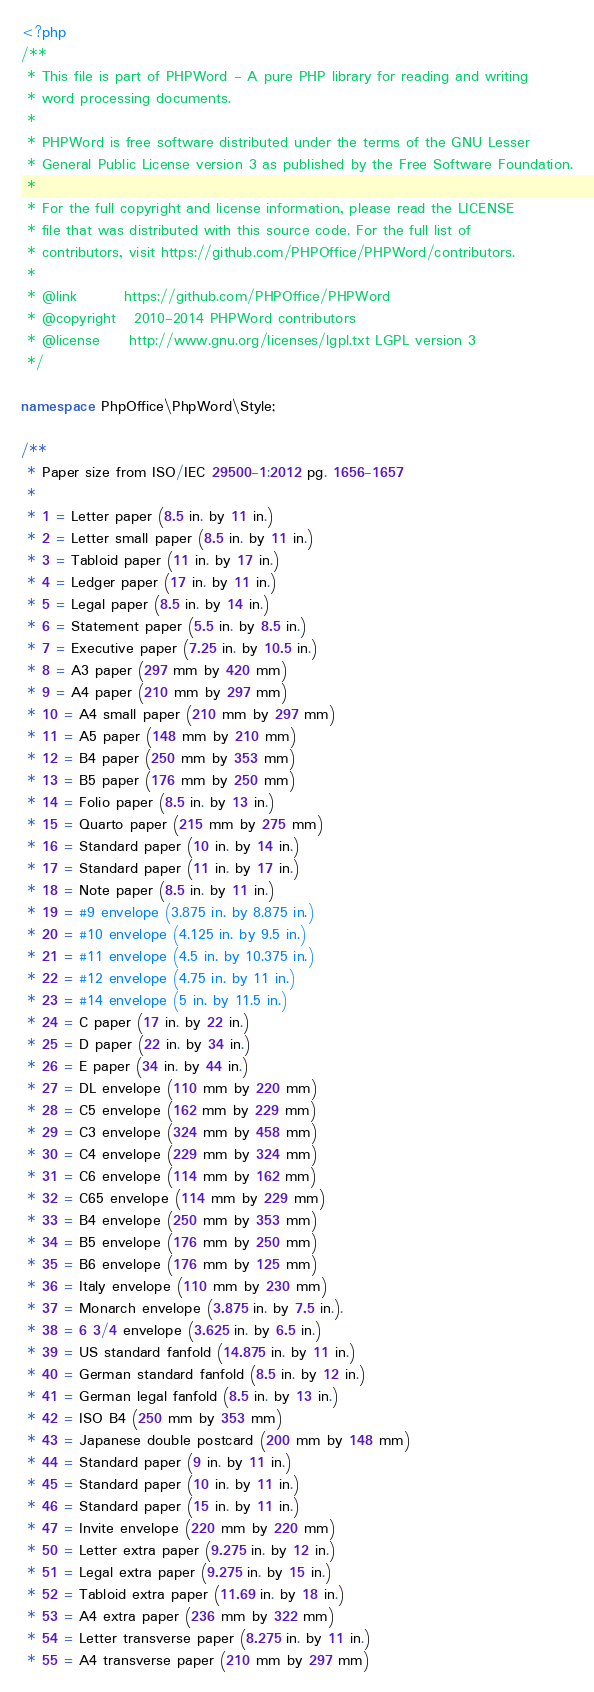<code> <loc_0><loc_0><loc_500><loc_500><_PHP_><?php
/**
 * This file is part of PHPWord - A pure PHP library for reading and writing
 * word processing documents.
 *
 * PHPWord is free software distributed under the terms of the GNU Lesser
 * General Public License version 3 as published by the Free Software Foundation.
 *
 * For the full copyright and license information, please read the LICENSE
 * file that was distributed with this source code. For the full list of
 * contributors, visit https://github.com/PHPOffice/PHPWord/contributors.
 *
 * @link        https://github.com/PHPOffice/PHPWord
 * @copyright   2010-2014 PHPWord contributors
 * @license     http://www.gnu.org/licenses/lgpl.txt LGPL version 3
 */

namespace PhpOffice\PhpWord\Style;

/**
 * Paper size from ISO/IEC 29500-1:2012 pg. 1656-1657
 *
 * 1 = Letter paper (8.5 in. by 11 in.)
 * 2 = Letter small paper (8.5 in. by 11 in.)
 * 3 = Tabloid paper (11 in. by 17 in.)
 * 4 = Ledger paper (17 in. by 11 in.)
 * 5 = Legal paper (8.5 in. by 14 in.)
 * 6 = Statement paper (5.5 in. by 8.5 in.)
 * 7 = Executive paper (7.25 in. by 10.5 in.)
 * 8 = A3 paper (297 mm by 420 mm)
 * 9 = A4 paper (210 mm by 297 mm)
 * 10 = A4 small paper (210 mm by 297 mm)
 * 11 = A5 paper (148 mm by 210 mm)
 * 12 = B4 paper (250 mm by 353 mm)
 * 13 = B5 paper (176 mm by 250 mm)
 * 14 = Folio paper (8.5 in. by 13 in.)
 * 15 = Quarto paper (215 mm by 275 mm)
 * 16 = Standard paper (10 in. by 14 in.)
 * 17 = Standard paper (11 in. by 17 in.)
 * 18 = Note paper (8.5 in. by 11 in.)
 * 19 = #9 envelope (3.875 in. by 8.875 in.)
 * 20 = #10 envelope (4.125 in. by 9.5 in.)
 * 21 = #11 envelope (4.5 in. by 10.375 in.)
 * 22 = #12 envelope (4.75 in. by 11 in.)
 * 23 = #14 envelope (5 in. by 11.5 in.)
 * 24 = C paper (17 in. by 22 in.)
 * 25 = D paper (22 in. by 34 in.)
 * 26 = E paper (34 in. by 44 in.)
 * 27 = DL envelope (110 mm by 220 mm)
 * 28 = C5 envelope (162 mm by 229 mm)
 * 29 = C3 envelope (324 mm by 458 mm)
 * 30 = C4 envelope (229 mm by 324 mm)
 * 31 = C6 envelope (114 mm by 162 mm)
 * 32 = C65 envelope (114 mm by 229 mm)
 * 33 = B4 envelope (250 mm by 353 mm)
 * 34 = B5 envelope (176 mm by 250 mm)
 * 35 = B6 envelope (176 mm by 125 mm)
 * 36 = Italy envelope (110 mm by 230 mm)
 * 37 = Monarch envelope (3.875 in. by 7.5 in.).
 * 38 = 6 3/4 envelope (3.625 in. by 6.5 in.)
 * 39 = US standard fanfold (14.875 in. by 11 in.)
 * 40 = German standard fanfold (8.5 in. by 12 in.)
 * 41 = German legal fanfold (8.5 in. by 13 in.)
 * 42 = ISO B4 (250 mm by 353 mm)
 * 43 = Japanese double postcard (200 mm by 148 mm)
 * 44 = Standard paper (9 in. by 11 in.)
 * 45 = Standard paper (10 in. by 11 in.)
 * 46 = Standard paper (15 in. by 11 in.)
 * 47 = Invite envelope (220 mm by 220 mm)
 * 50 = Letter extra paper (9.275 in. by 12 in.)
 * 51 = Legal extra paper (9.275 in. by 15 in.)
 * 52 = Tabloid extra paper (11.69 in. by 18 in.)
 * 53 = A4 extra paper (236 mm by 322 mm)
 * 54 = Letter transverse paper (8.275 in. by 11 in.)
 * 55 = A4 transverse paper (210 mm by 297 mm)</code> 